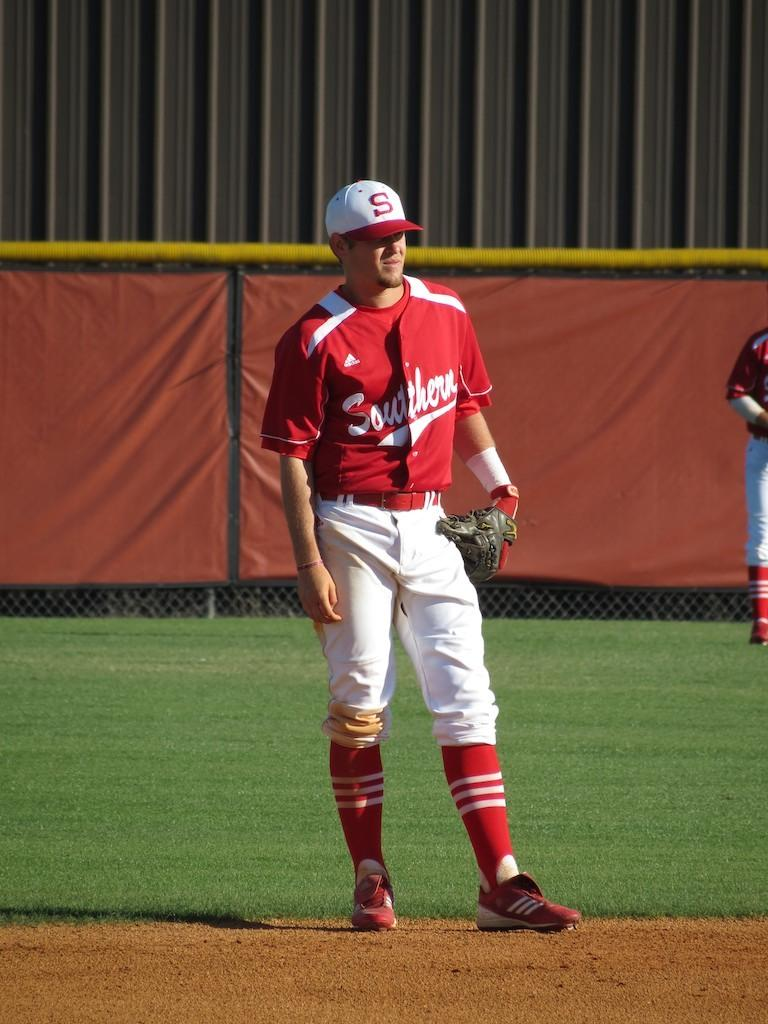<image>
Render a clear and concise summary of the photo. The baseball player is wearing a red and white uniform and his jersey says Southern. 